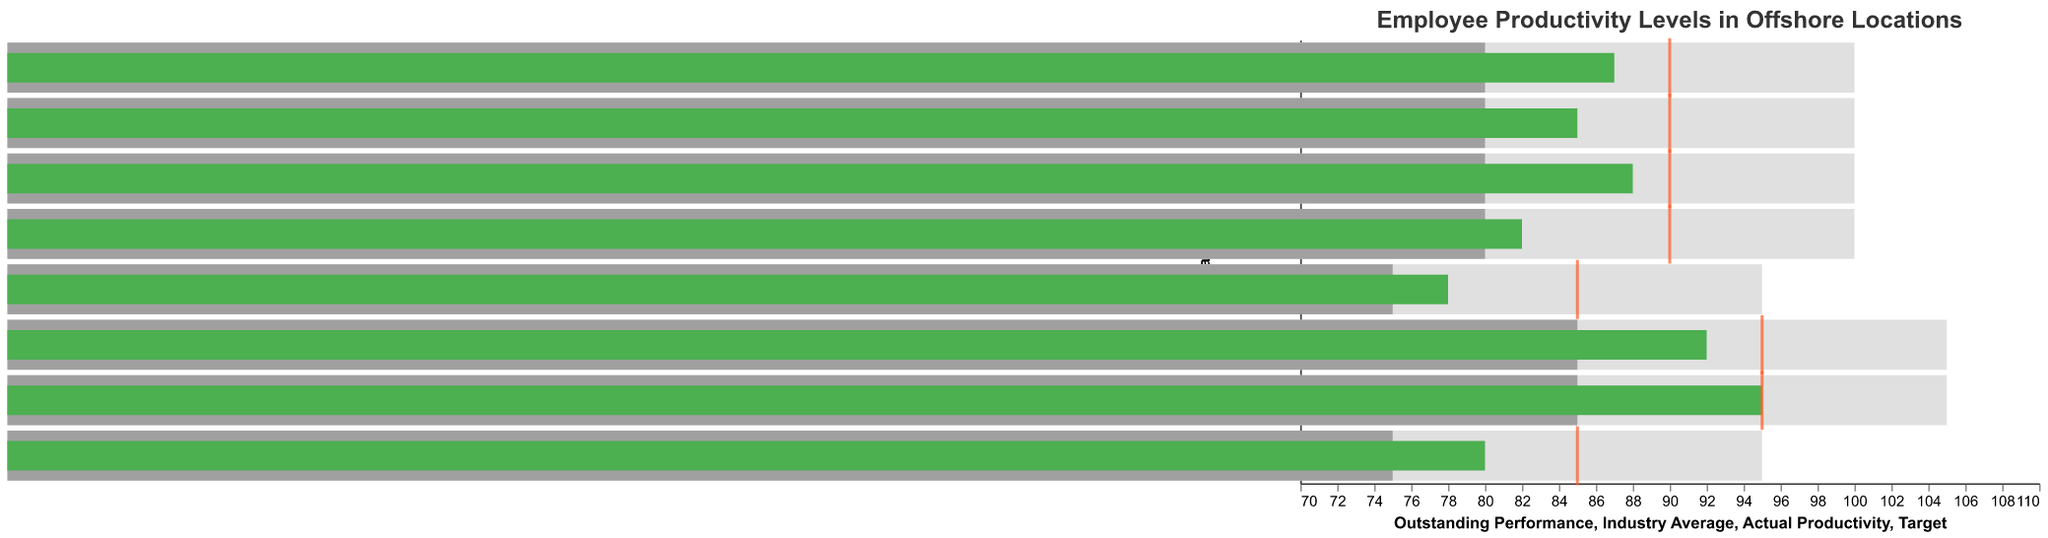What's the title of the figure? The title of the figure is displayed at the top and describes the content. The title is "Employee Productivity Levels in Offshore Locations."
Answer: Employee Productivity Levels in Offshore Locations How many offshore locations are presented in the figure? By counting the unique names on the y-axis, we can see there are eight offshore locations listed.
Answer: Eight Which offshore location has the highest actual productivity? By examining the green bars representing "Actual Productivity," we find that "Ukraine" has the highest value at 95.
Answer: Ukraine What is the industry average productivity for Poland? The grey bar represents the "Industry Average." For Poland, this bar extends to 85.
Answer: 85 Among the locations, which ones meet or exceed their target productivity? By comparing the green bars and red ticks, we find "Poland" and "Ukraine" have their green bars reaching the red tick marks, meaning they meet or exceed their target productivity.
Answer: Poland and Ukraine What is the difference between the actual and target productivity for Vietnam? The green bar represents actual productivity, and the red tick represents target productivity. For Vietnam, the actual productivity is 80 and the target is 85. The difference is 85 - 80.
Answer: 5 Which location has an actual productivity level equal to the industry average? Comparing the lengths of the green bars and grey bars, we see that no location's actual productivity equals the industry average.
Answer: None How does Mexico's actual productivity compare to the industry average and target productivity? Mexico’s actual productivity is 82 (green bar), the industry average is 80 (grey bar), and the target is 90 (red tick). Mexico's actual productivity is above the industry average but below the target.
Answer: Above the industry average, below the target What is the outstanding performance benchmark for Malaysia? By looking at the length of the widest bar in the background for Malaysia, the "Outstanding Performance" is 100.
Answer: 100 Which location has the widest gap between actual productivity and outstanding performance? This would mean the largest difference between the green bar and the background bar. For Costa Rica, actual productivity is 87, outstanding performance is 100. The gap is 100 - 87 = 13. Other locations have smaller gaps.
Answer: Costa Rica 